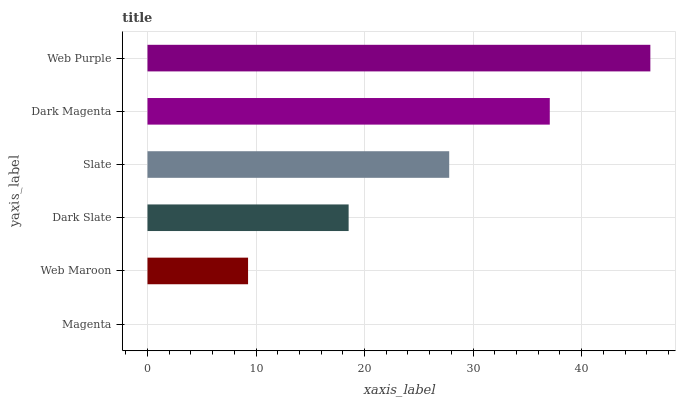Is Magenta the minimum?
Answer yes or no. Yes. Is Web Purple the maximum?
Answer yes or no. Yes. Is Web Maroon the minimum?
Answer yes or no. No. Is Web Maroon the maximum?
Answer yes or no. No. Is Web Maroon greater than Magenta?
Answer yes or no. Yes. Is Magenta less than Web Maroon?
Answer yes or no. Yes. Is Magenta greater than Web Maroon?
Answer yes or no. No. Is Web Maroon less than Magenta?
Answer yes or no. No. Is Slate the high median?
Answer yes or no. Yes. Is Dark Slate the low median?
Answer yes or no. Yes. Is Dark Magenta the high median?
Answer yes or no. No. Is Magenta the low median?
Answer yes or no. No. 